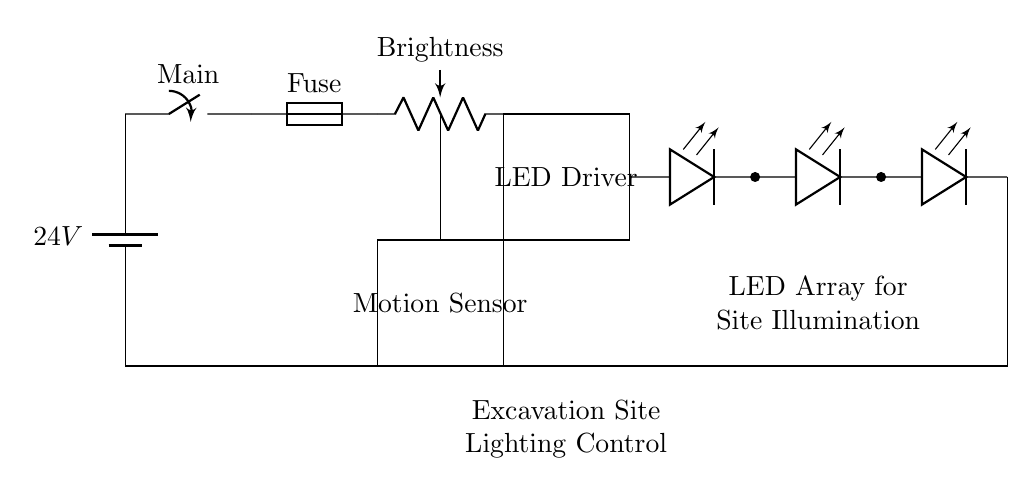What is the voltage of the power supply? The voltage of the power supply is indicated as 24V in the circuit diagram. This is explicitly marked next to the battery symbol, which shows that the power supply provides this potential difference.
Answer: 24V What component is used for brightness control? The component used for brightness control in the circuit is labeled as "Brightness" and is represented by the potentiometer symbol (pR). This indicates that the brightness can be adjusted through this component.
Answer: Potentiometer What function does the motion sensor serve in this circuit? The motion sensor is labeled in the circuit diagram and serves to detect motion within the excavation site. Its output can activate the lighting circuit when motion is detected, providing illumination when needed.
Answer: Activation How many LED arrays are present in the circuit? There are four LED arrays in the circuit as indicated by the four consecutive LED symbols (leDo). Each LED symbol represents one array, collectively providing illumination for the site.
Answer: Four What is the purpose of the fuse in this circuit? The fuse is included in the circuit diagram to protect against overcurrent conditions. It is designed to disconnect the circuit if the current exceeds a safe level, preventing potential damage to other components.
Answer: Protection What does the rectangle labeled "LED Driver" indicate? The rectangle labeled "LED Driver" signifies that this component regulates the current supplied to the LED arrays. It ensures the LEDs operate efficiently and prevents damage due to excessive current.
Answer: Current regulation What is the overall function of this lighting control circuit? The overall function of the lighting control circuit is to provide adjustable illumination for excavation sites based on the detected motion, ensuring safety and visibility while conserving energy.
Answer: Adjustable illumination 